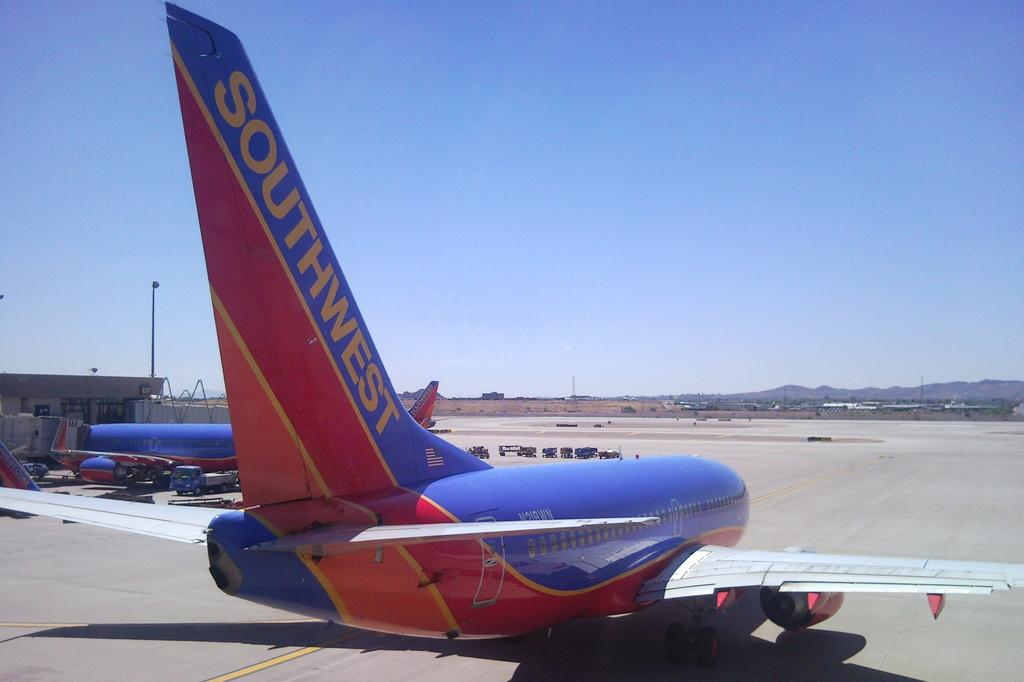<image>
Give a short and clear explanation of the subsequent image. A red, yellow, and blue plane with SOUTHWEST on the tail is at the airport. 